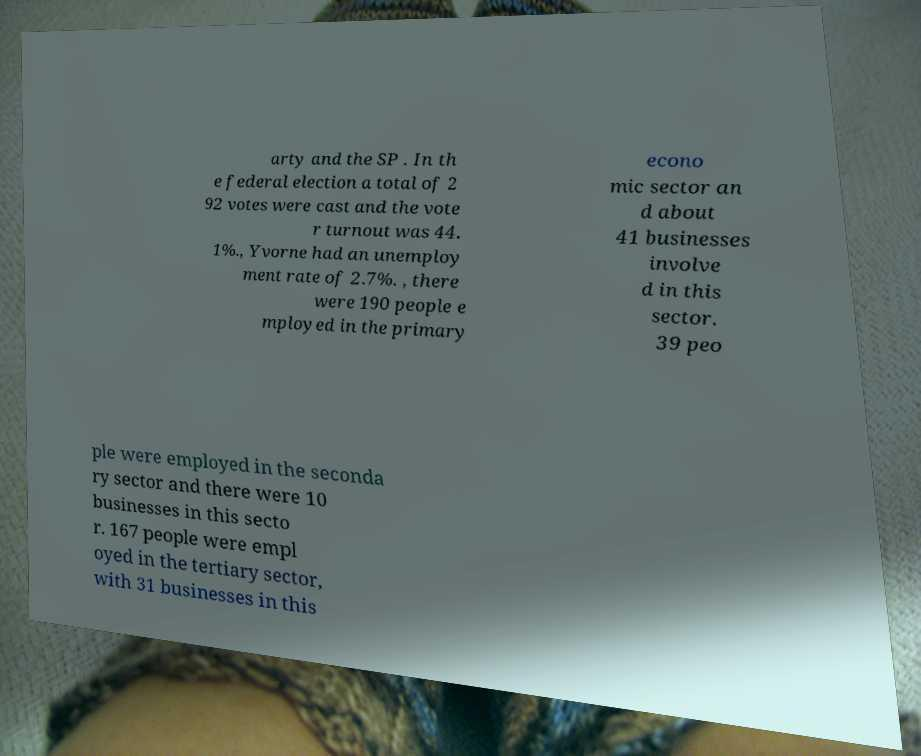There's text embedded in this image that I need extracted. Can you transcribe it verbatim? arty and the SP . In th e federal election a total of 2 92 votes were cast and the vote r turnout was 44. 1%., Yvorne had an unemploy ment rate of 2.7%. , there were 190 people e mployed in the primary econo mic sector an d about 41 businesses involve d in this sector. 39 peo ple were employed in the seconda ry sector and there were 10 businesses in this secto r. 167 people were empl oyed in the tertiary sector, with 31 businesses in this 